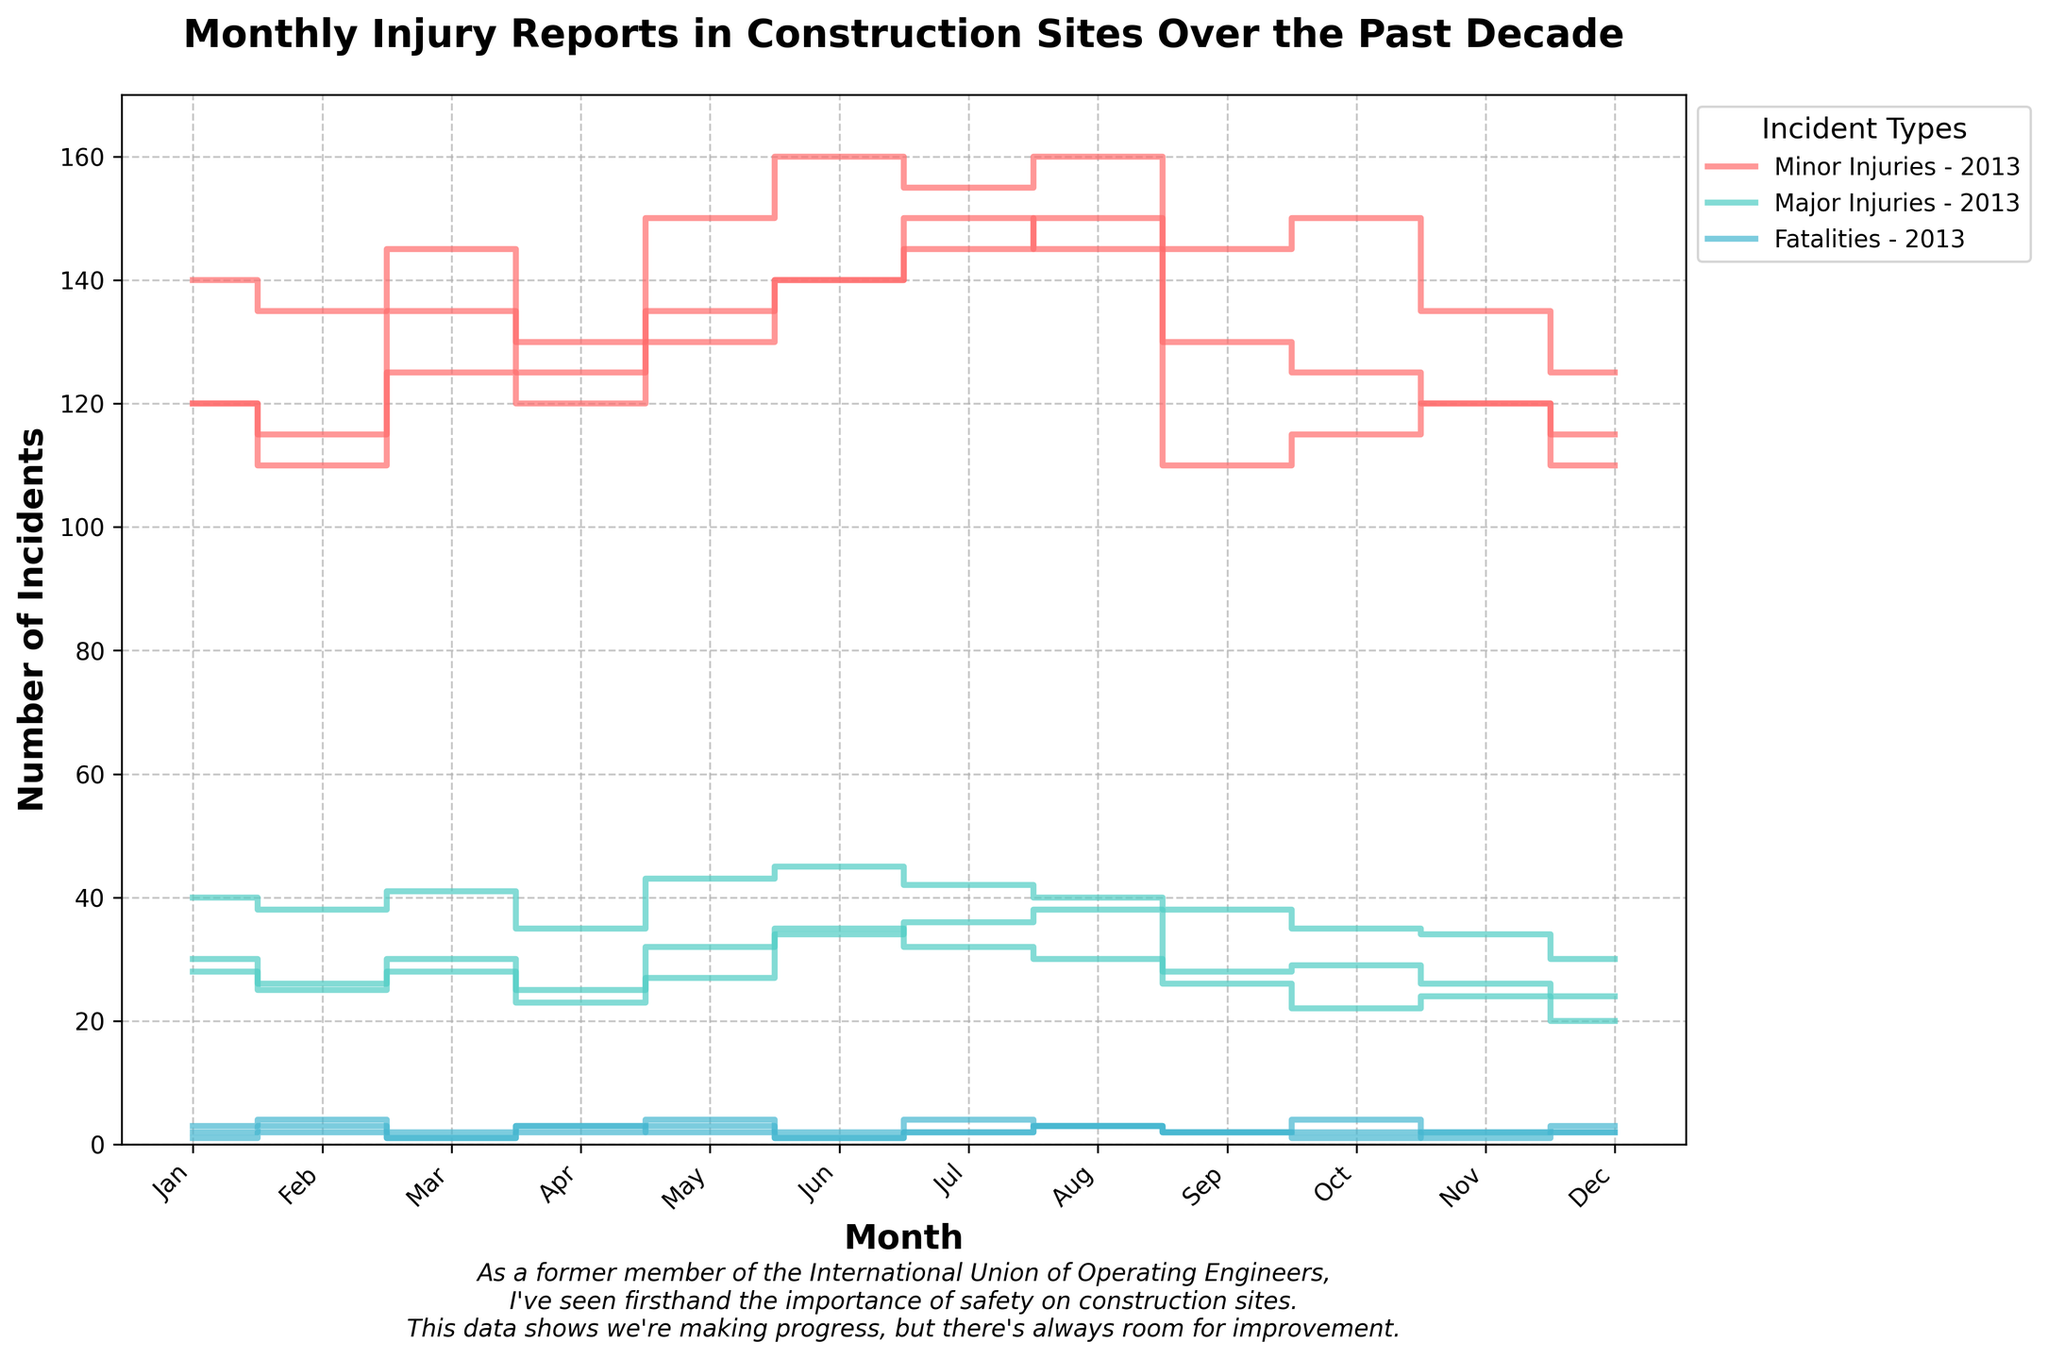What's the title of the figure? The title of the figure is usually displayed at the top. In this figure, the title provides an overall description of the plot, which is "Monthly Injury Reports in Construction Sites Over the Past Decade".
Answer: Monthly Injury Reports in Construction Sites Over the Past Decade How many types of incidents are displayed in the plot? The figure shows lines for three types of incidents, each corresponding to a different color: Minor Injuries, Major Injuries, and Fatalities. You can see these types in the plot label or the legend.
Answer: Three Which month in 2018 had the highest number of minor injuries? The plot shows stepped lines for each category over 12 months. For minor injuries in 2018, the peak appears to be in June with the highest step reaching up to near 160.
Answer: June In which year did minor injuries tend to be the highest overall? By comparing the height of the 'Minor Injuries' line across different years, 2018 tends to have higher values overall compared to 2013 and 2023.
Answer: 2018 How do major injuries in December compare across the three years? December data points for major injuries from the three years can be compared visually by the heights of their respective steps. December 2018 has the highest, followed by December 2023 and the lowest is December 2013.
Answer: December 2018 > December 2023 > December 2013 Were there more major injuries or minor injuries in July 2023? To find this, look at the height of the steps for July 2023. The 'Minor Injuries' line is higher compared to the 'Major Injuries' line, indicating there were more minor injuries.
Answer: Minor Injuries Which year had the most fatalities in May? To determine this, check the height of the fatalities line for May across the three years. 2018 shows the highest step for fatalities.
Answer: 2018 What is the general trend for the number of fatalities over the three years? The trend for fatalities can be observed by comparing the lines across years. 2018 shows generally higher fatalities, sometimes remaining constant or slightly decreasing in 2023 when compared to 2013.
Answer: Slightly decreasing from 2018 to 2023 What's the difference in major injuries between January 2013 and January 2023? Identify the steps for major injuries in January for both years. January 2013 has 30, and January 2023 has 28, yielding a difference of 30 - 28.
Answer: 2 Are there any months where the number of minor injuries did not change significantly between 2013 and 2023? By comparing the steps side-by-side for 2013 and 2023 minor injuries, look for months where the heights are nearly equal. December is one such month with about 110 in 2013 and 115 in 2023, showing little change.
Answer: December 